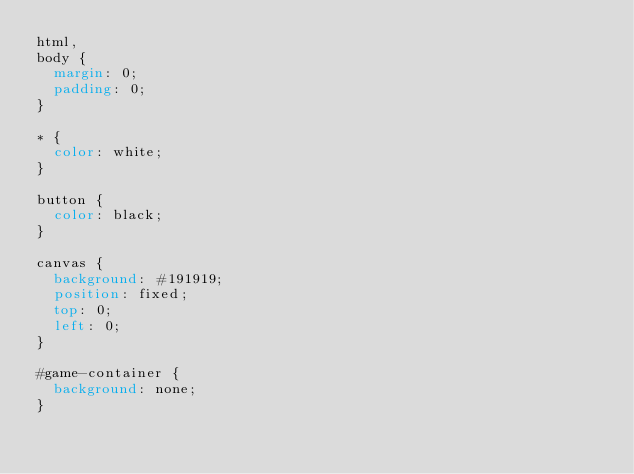<code> <loc_0><loc_0><loc_500><loc_500><_CSS_>html,
body {
  margin: 0;
  padding: 0;
}

* {
  color: white;
}

button {
  color: black;
}

canvas {
  background: #191919;
  position: fixed;
  top: 0;
  left: 0;
}

#game-container {
  background: none;
}
</code> 